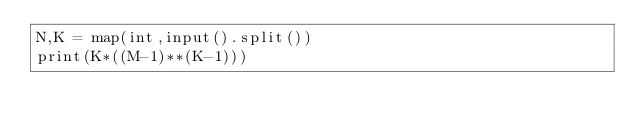<code> <loc_0><loc_0><loc_500><loc_500><_Python_>N,K = map(int,input().split())
print(K*((M-1)**(K-1)))</code> 